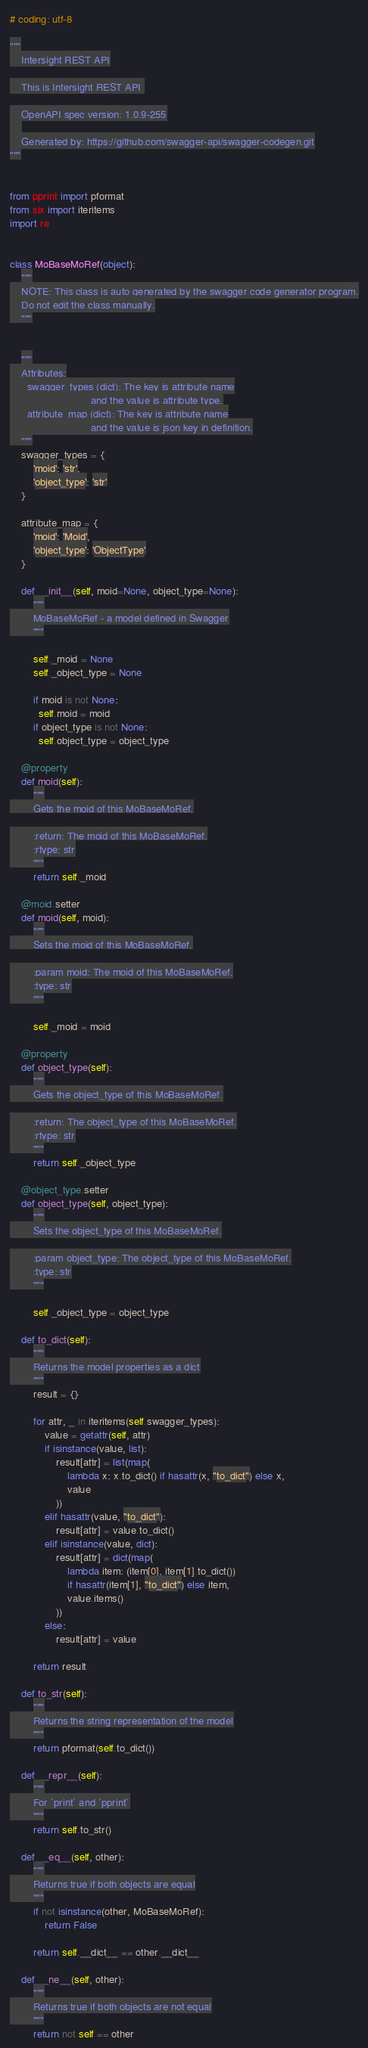<code> <loc_0><loc_0><loc_500><loc_500><_Python_># coding: utf-8

"""
    Intersight REST API

    This is Intersight REST API 

    OpenAPI spec version: 1.0.9-255
    
    Generated by: https://github.com/swagger-api/swagger-codegen.git
"""


from pprint import pformat
from six import iteritems
import re


class MoBaseMoRef(object):
    """
    NOTE: This class is auto generated by the swagger code generator program.
    Do not edit the class manually.
    """


    """
    Attributes:
      swagger_types (dict): The key is attribute name
                            and the value is attribute type.
      attribute_map (dict): The key is attribute name
                            and the value is json key in definition.
    """
    swagger_types = {
        'moid': 'str',
        'object_type': 'str'
    }

    attribute_map = {
        'moid': 'Moid',
        'object_type': 'ObjectType'
    }

    def __init__(self, moid=None, object_type=None):
        """
        MoBaseMoRef - a model defined in Swagger
        """

        self._moid = None
        self._object_type = None

        if moid is not None:
          self.moid = moid
        if object_type is not None:
          self.object_type = object_type

    @property
    def moid(self):
        """
        Gets the moid of this MoBaseMoRef.

        :return: The moid of this MoBaseMoRef.
        :rtype: str
        """
        return self._moid

    @moid.setter
    def moid(self, moid):
        """
        Sets the moid of this MoBaseMoRef.

        :param moid: The moid of this MoBaseMoRef.
        :type: str
        """

        self._moid = moid

    @property
    def object_type(self):
        """
        Gets the object_type of this MoBaseMoRef.

        :return: The object_type of this MoBaseMoRef.
        :rtype: str
        """
        return self._object_type

    @object_type.setter
    def object_type(self, object_type):
        """
        Sets the object_type of this MoBaseMoRef.

        :param object_type: The object_type of this MoBaseMoRef.
        :type: str
        """

        self._object_type = object_type

    def to_dict(self):
        """
        Returns the model properties as a dict
        """
        result = {}

        for attr, _ in iteritems(self.swagger_types):
            value = getattr(self, attr)
            if isinstance(value, list):
                result[attr] = list(map(
                    lambda x: x.to_dict() if hasattr(x, "to_dict") else x,
                    value
                ))
            elif hasattr(value, "to_dict"):
                result[attr] = value.to_dict()
            elif isinstance(value, dict):
                result[attr] = dict(map(
                    lambda item: (item[0], item[1].to_dict())
                    if hasattr(item[1], "to_dict") else item,
                    value.items()
                ))
            else:
                result[attr] = value

        return result

    def to_str(self):
        """
        Returns the string representation of the model
        """
        return pformat(self.to_dict())

    def __repr__(self):
        """
        For `print` and `pprint`
        """
        return self.to_str()

    def __eq__(self, other):
        """
        Returns true if both objects are equal
        """
        if not isinstance(other, MoBaseMoRef):
            return False

        return self.__dict__ == other.__dict__

    def __ne__(self, other):
        """
        Returns true if both objects are not equal
        """
        return not self == other
</code> 